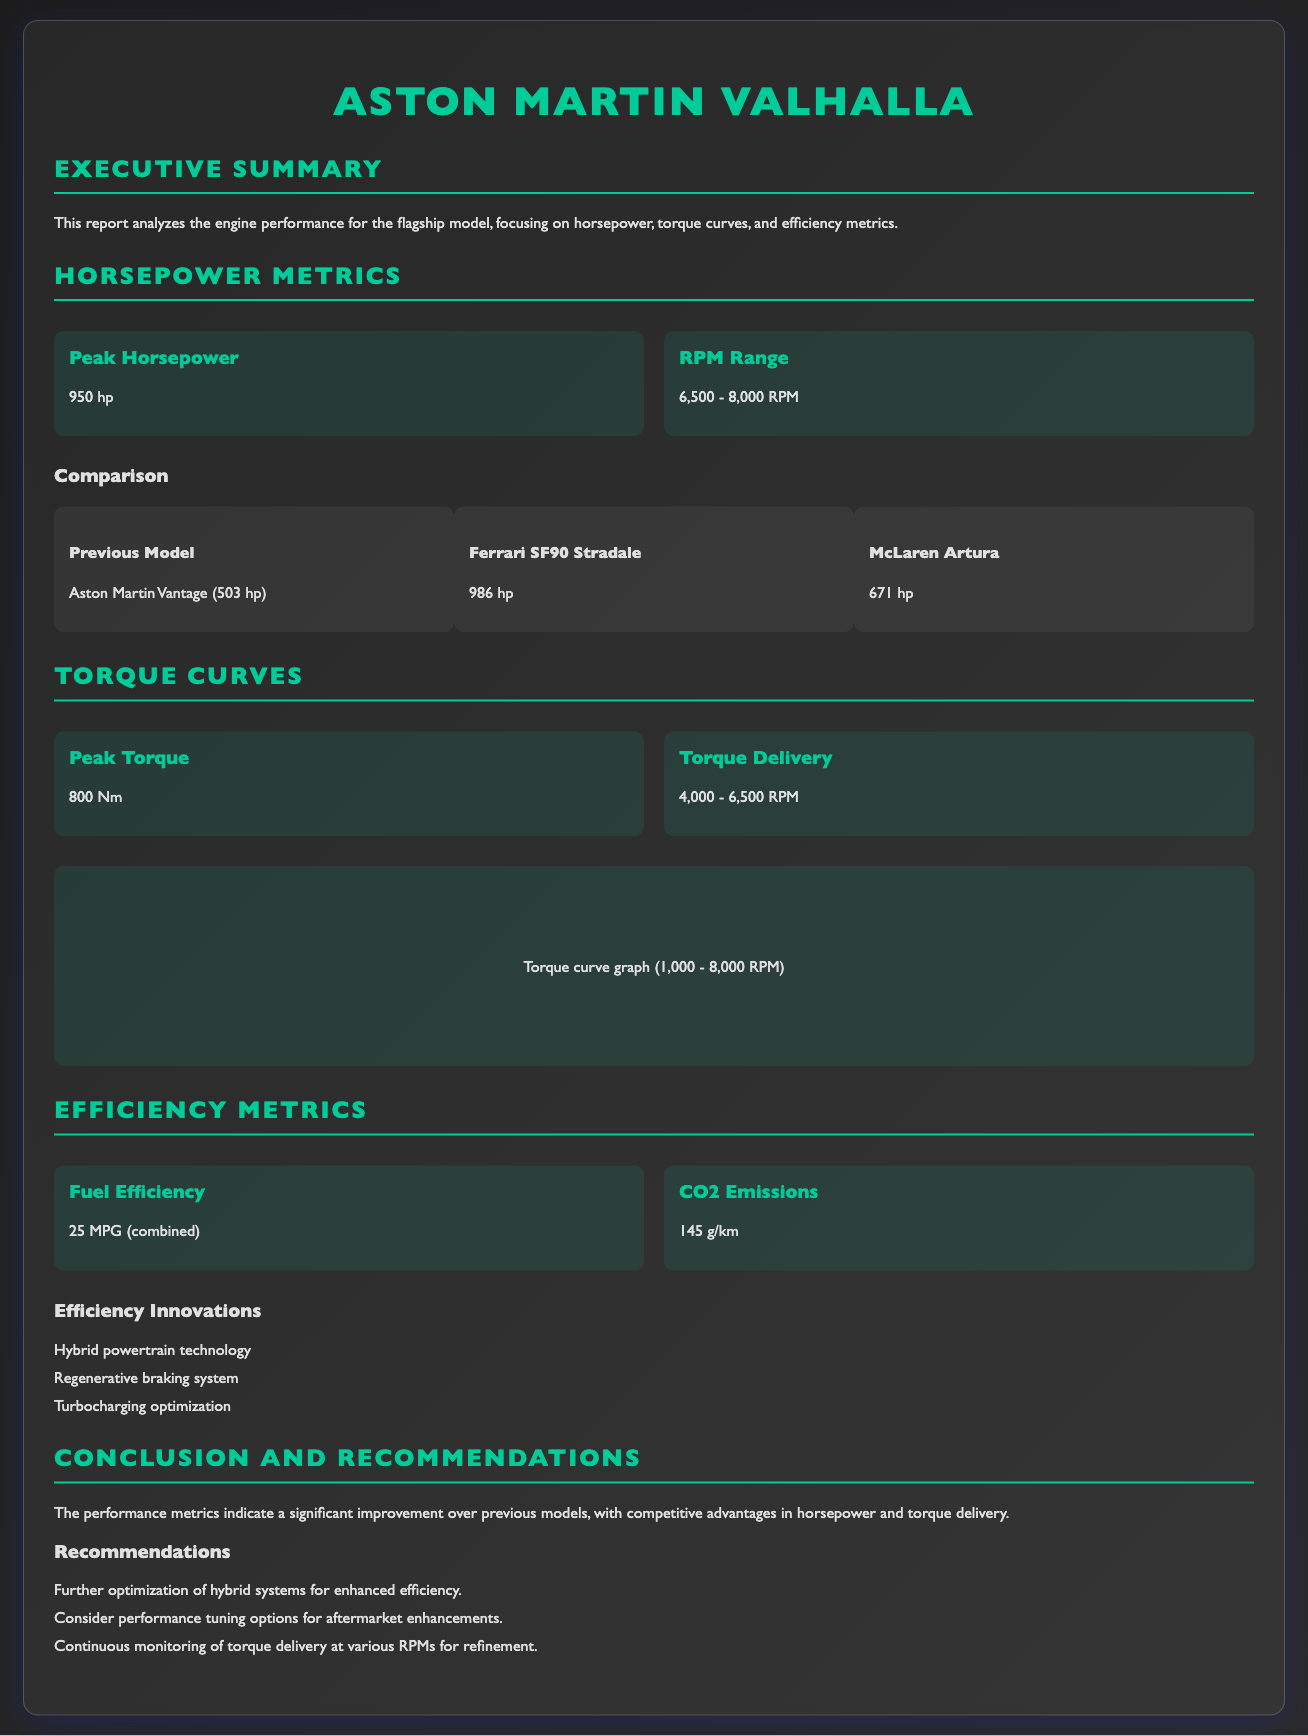What is the peak horsepower of the flagship model? The peak horsepower is explicitly stated in the document.
Answer: 950 hp What is the RPM range for peak horsepower? The document provides specific RPM ranges for horsepower.
Answer: 6,500 - 8,000 RPM What is the peak torque of the engine? The peak torque is a key performance metric mentioned in the report.
Answer: 800 Nm What is the fuel efficiency reported in the document? The document indicates the fuel efficiency as a specific value.
Answer: 25 MPG (combined) What are the CO2 emissions for the flagship model? The document states CO2 emissions as a quantitative metric.
Answer: 145 g/km Which vehicle has a peak horsepower lower than the flagship model? This question involves comparing the horsepower metrics between models.
Answer: Aston Martin Vantage What is the torque delivery RPM range? The document specifies the RPM range for torque delivery.
Answer: 4,000 - 6,500 RPM Name one efficiency innovation mentioned in the report. The document lists several innovations related to efficiency metrics.
Answer: Hybrid powertrain technology What conclusion is drawn regarding performance metrics? The conclusion summarizing performance improvements is present in the document.
Answer: Significant improvement over previous models 